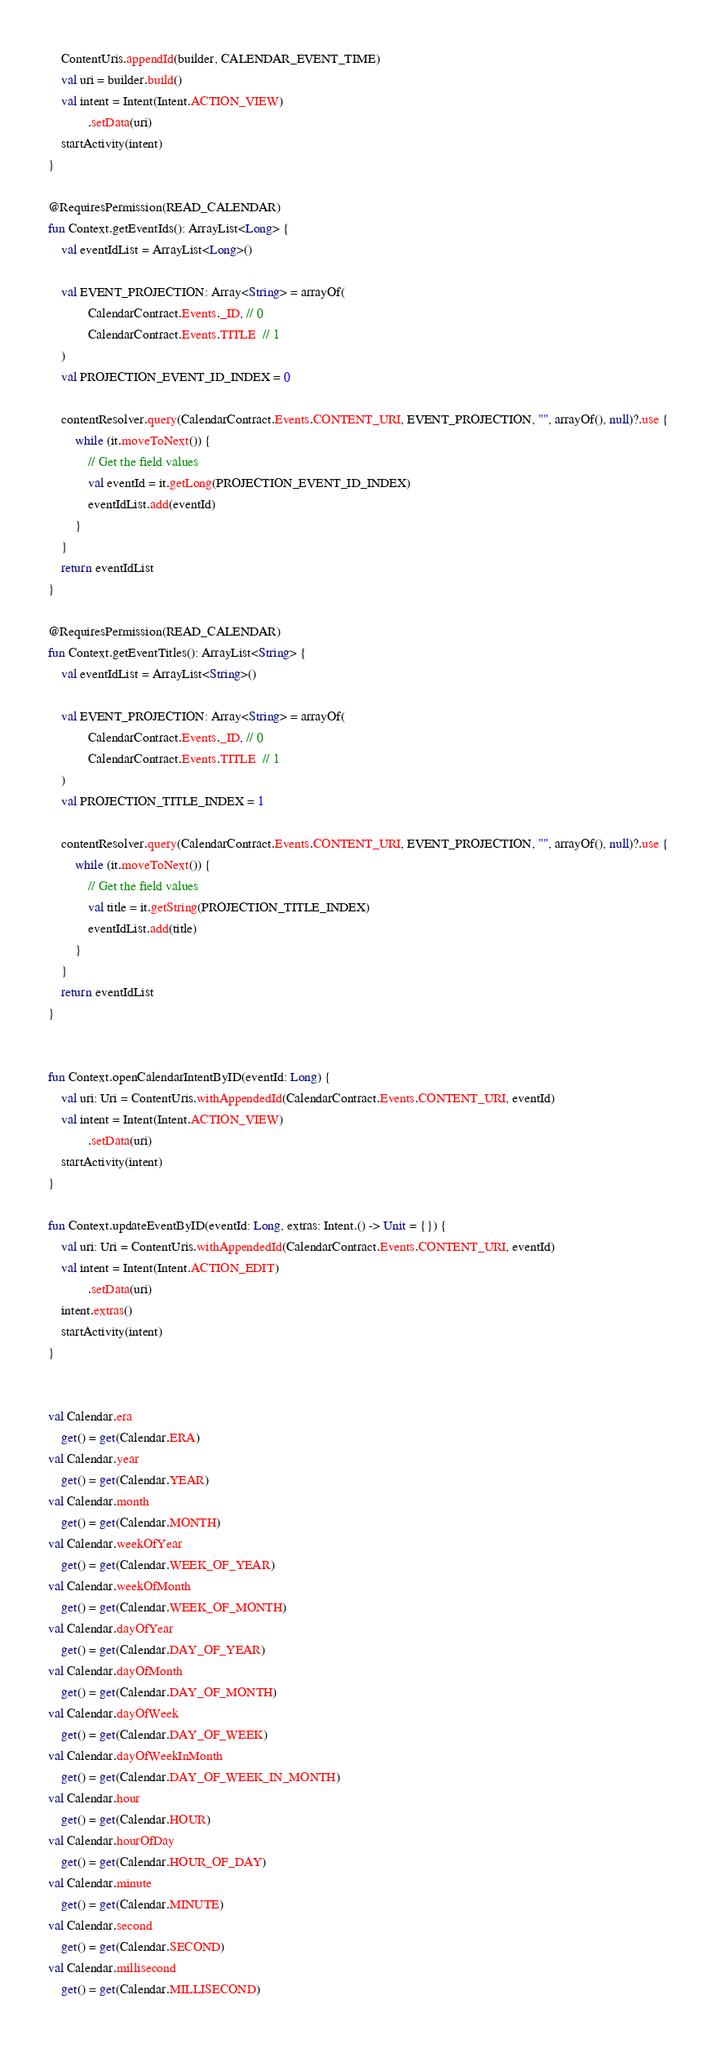Convert code to text. <code><loc_0><loc_0><loc_500><loc_500><_Kotlin_>    ContentUris.appendId(builder, CALENDAR_EVENT_TIME)
    val uri = builder.build()
    val intent = Intent(Intent.ACTION_VIEW)
            .setData(uri)
    startActivity(intent)
}

@RequiresPermission(READ_CALENDAR)
fun Context.getEventIds(): ArrayList<Long> {
    val eventIdList = ArrayList<Long>()

    val EVENT_PROJECTION: Array<String> = arrayOf(
            CalendarContract.Events._ID, // 0
            CalendarContract.Events.TITLE  // 1
    )
    val PROJECTION_EVENT_ID_INDEX = 0

    contentResolver.query(CalendarContract.Events.CONTENT_URI, EVENT_PROJECTION, "", arrayOf(), null)?.use {
        while (it.moveToNext()) {
            // Get the field values
            val eventId = it.getLong(PROJECTION_EVENT_ID_INDEX)
            eventIdList.add(eventId)
        }
    }
    return eventIdList
}

@RequiresPermission(READ_CALENDAR)
fun Context.getEventTitles(): ArrayList<String> {
    val eventIdList = ArrayList<String>()

    val EVENT_PROJECTION: Array<String> = arrayOf(
            CalendarContract.Events._ID, // 0
            CalendarContract.Events.TITLE  // 1
    )
    val PROJECTION_TITLE_INDEX = 1

    contentResolver.query(CalendarContract.Events.CONTENT_URI, EVENT_PROJECTION, "", arrayOf(), null)?.use {
        while (it.moveToNext()) {
            // Get the field values
            val title = it.getString(PROJECTION_TITLE_INDEX)
            eventIdList.add(title)
        }
    }
    return eventIdList
}


fun Context.openCalendarIntentByID(eventId: Long) {
    val uri: Uri = ContentUris.withAppendedId(CalendarContract.Events.CONTENT_URI, eventId)
    val intent = Intent(Intent.ACTION_VIEW)
            .setData(uri)
    startActivity(intent)
}

fun Context.updateEventByID(eventId: Long, extras: Intent.() -> Unit = {}) {
    val uri: Uri = ContentUris.withAppendedId(CalendarContract.Events.CONTENT_URI, eventId)
    val intent = Intent(Intent.ACTION_EDIT)
            .setData(uri)
    intent.extras()
    startActivity(intent)
}


val Calendar.era
    get() = get(Calendar.ERA)
val Calendar.year
    get() = get(Calendar.YEAR)
val Calendar.month
    get() = get(Calendar.MONTH)
val Calendar.weekOfYear
    get() = get(Calendar.WEEK_OF_YEAR)
val Calendar.weekOfMonth
    get() = get(Calendar.WEEK_OF_MONTH)
val Calendar.dayOfYear
    get() = get(Calendar.DAY_OF_YEAR)
val Calendar.dayOfMonth
    get() = get(Calendar.DAY_OF_MONTH)
val Calendar.dayOfWeek
    get() = get(Calendar.DAY_OF_WEEK)
val Calendar.dayOfWeekInMonth
    get() = get(Calendar.DAY_OF_WEEK_IN_MONTH)
val Calendar.hour
    get() = get(Calendar.HOUR)
val Calendar.hourOfDay
    get() = get(Calendar.HOUR_OF_DAY)
val Calendar.minute
    get() = get(Calendar.MINUTE)
val Calendar.second
    get() = get(Calendar.SECOND)
val Calendar.millisecond
    get() = get(Calendar.MILLISECOND)


</code> 